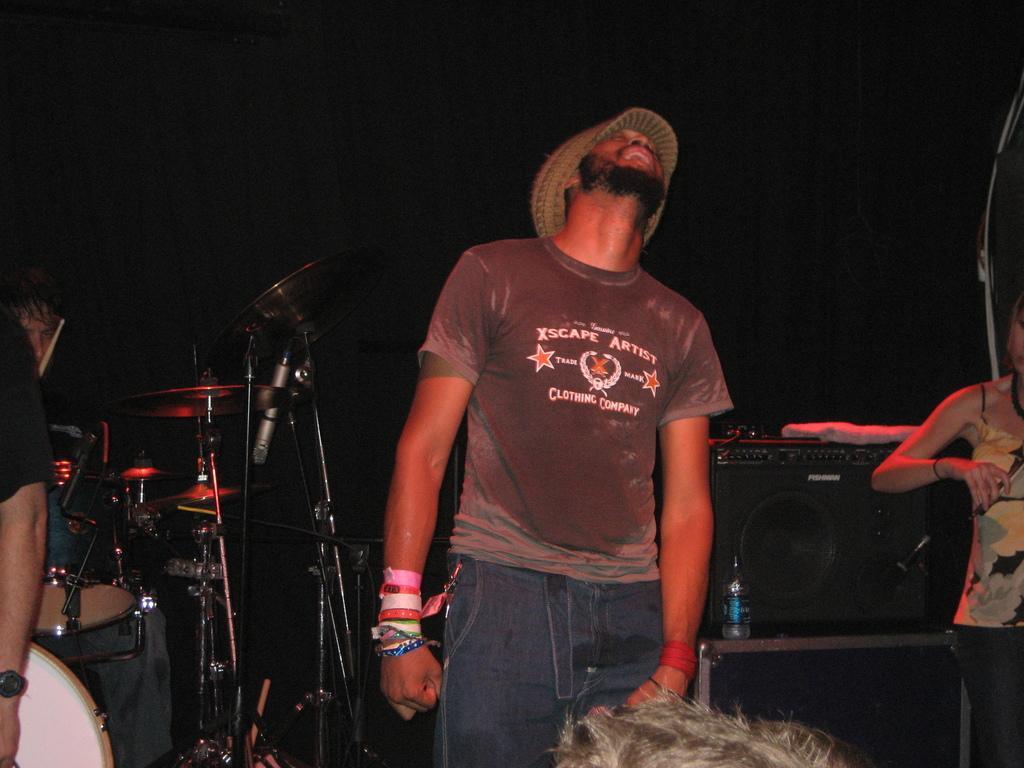How would you summarize this image in a sentence or two? Here we can see man in the center looking towards the upward side and beside him there are musical instruments with other people present 